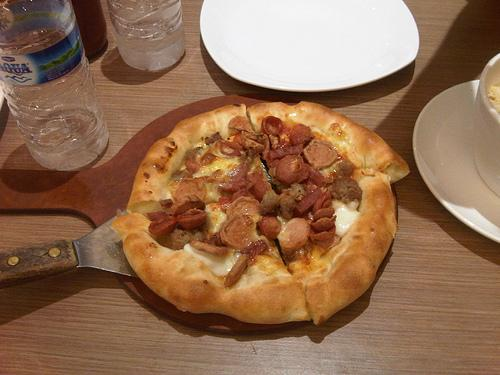What is under the food?

Choices:
A) box
B) spatula
C) sugar
D) egg spatula 